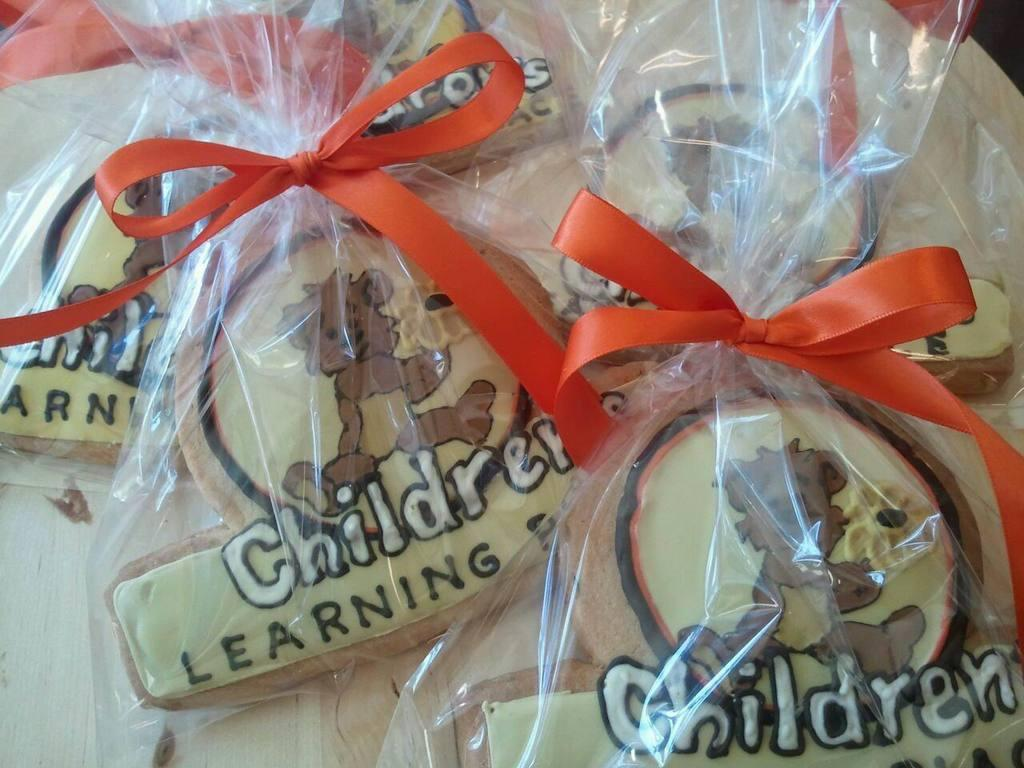What is the color of the objects in plastic covers in the image? The objects in plastic covers are cream-colored. What other items can be seen in the image? There are orange-colored ribbons in the image. What is written on the cream-colored objects? Something is written on the cream-colored objects. What type of school event is taking place in the image? There is no indication of a school event or any school-related context in the image. 